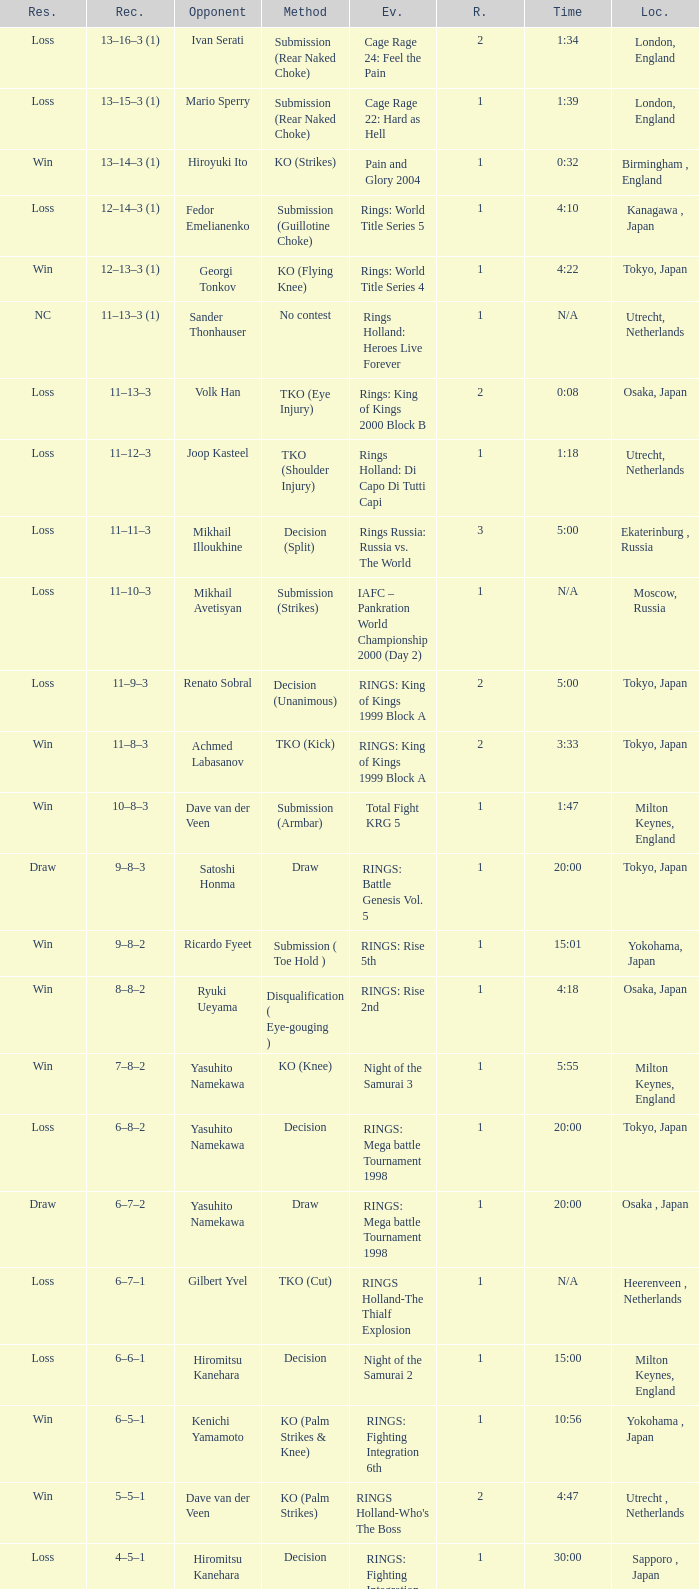What is the time for Moscow, Russia? N/A. 